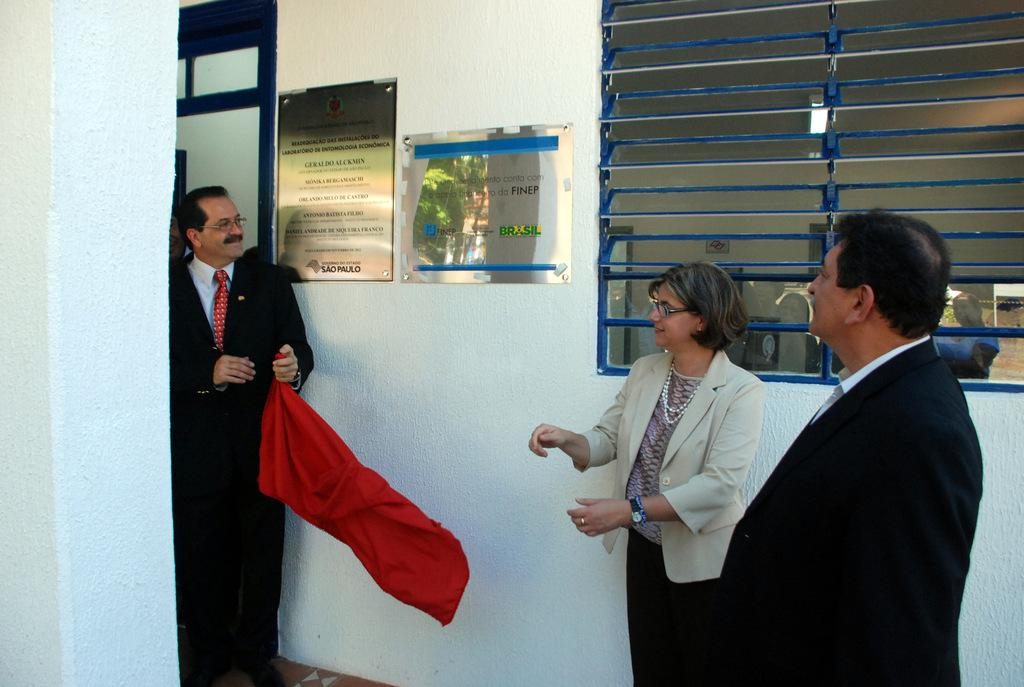How many people are in the image? There are two men and a woman in the image. What is one of the men holding? One man is holding a red cloth. What is the surface beneath the people's feet in the image? There is a floor in the image. What can be seen on the wall in the background? There are frames on the wall in the background. What is visible outside the window in the background? There is a window in the background, but the image does not show what is visible outside. What type of tub is visible in the image? There is no tub present in the image. What offer is the woman making to the men in the image? The image does not show any offers being made, as it only depicts the people and their surroundings. 